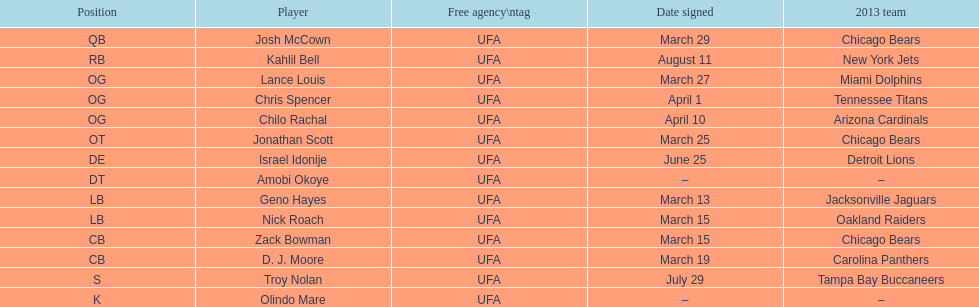His/her first name is the same name as a country. Israel Idonije. 